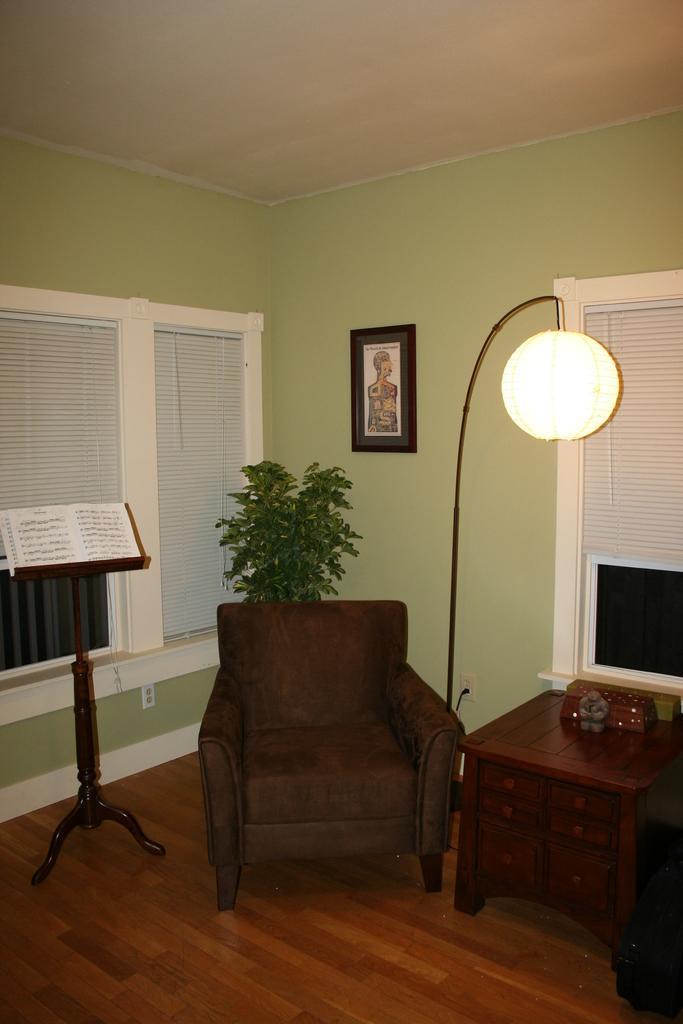Can you describe this image briefly? In this picture there are things like chair, table, stand, light, walls, and photo frame. 